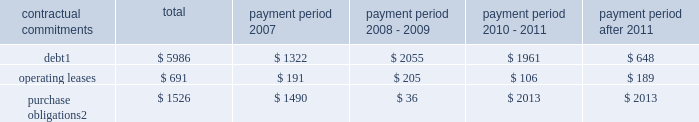Part ii , item 7 in 2006 , cash provided by financing activities was $ 291 million which was primarily due to the proceeds from employee stock plans ( $ 442 million ) and an increase in debt of $ 1.5 billion partially offset by the repurchase of 17.99 million shares of schlumberger stock ( $ 1.07 billion ) and the payment of dividends to shareholders ( $ 568 million ) .
Schlumberger believes that at december 31 , 2006 , cash and short-term investments of $ 3.0 billion and available and unused credit facilities of $ 2.2 billion are sufficient to meet future business requirements for at least the next twelve months .
Summary of major contractual commitments ( stated in millions ) .
Purchase obligations 2 $ 1526 $ 1490 $ 36 $ 2013 $ 2013 1 .
Excludes future payments for interest .
Includes amounts relating to the $ 1425 million of convertible debentures which are described in note 11 of the consolidated financial statements .
Represents an estimate of contractual obligations in the ordinary course of business .
Although these contractual obligations are considered enforceable and legally binding , the terms generally allow schlumberger the option to reschedule and adjust their requirements based on business needs prior to the delivery of goods .
Refer to note 4 of the consolidated financial statements for details regarding potential commitments associated with schlumberger 2019s prior business acquisitions .
Refer to note 20 of the consolidated financial statements for details regarding schlumberger 2019s pension and other postretirement benefit obligations .
Schlumberger has outstanding letters of credit/guarantees which relate to business performance bonds , custom/excise tax commitments , facility lease/rental obligations , etc .
These were entered into in the ordinary course of business and are customary practices in the various countries where schlumberger operates .
Critical accounting policies and estimates the preparation of financial statements and related disclosures in conformity with accounting principles generally accepted in the united states requires schlumberger to make estimates and assumptions that affect the reported amounts of assets and liabilities , the disclosure of contingent assets and liabilities and the reported amounts of revenue and expenses .
The following accounting policies involve 201ccritical accounting estimates 201d because they are particularly dependent on estimates and assumptions made by schlumberger about matters that are inherently uncertain .
A summary of all of schlumberger 2019s significant accounting policies is included in note 2 to the consolidated financial statements .
Schlumberger bases its estimates on historical experience and on various other assumptions that are believed to be reasonable under the circumstances , the results of which form the basis for making judgments about the carrying values of assets and liabilities that are not readily apparent from other sources .
Actual results may differ from these estimates under different assumptions or conditions .
Multiclient seismic data the westerngeco segment capitalizes the costs associated with obtaining multiclient seismic data .
The carrying value of the multiclient seismic data library at december 31 , 2006 , 2005 and 2004 was $ 227 million , $ 222 million and $ 347 million , respectively .
Such costs are charged to cost of goods sold and services based on the percentage of the total costs to the estimated total revenue that schlumberger expects to receive from the sales of such data .
However , except as described below under 201cwesterngeco purchase accounting , 201d under no circumstance will an individual survey carry a net book value greater than a 4-year straight-lined amortized value. .
What is the ratio of the total debt to the purchase obligations? 
Rationale: every dollar of purchase obligation is funded by 3.92 in debt
Computations: (5986 / 1526)
Answer: 3.92267. 